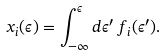Convert formula to latex. <formula><loc_0><loc_0><loc_500><loc_500>x _ { i } ( \epsilon ) = \int _ { - \infty } ^ { \epsilon } d \epsilon ^ { \prime } \, f _ { i } ( \epsilon ^ { \prime } ) .</formula> 